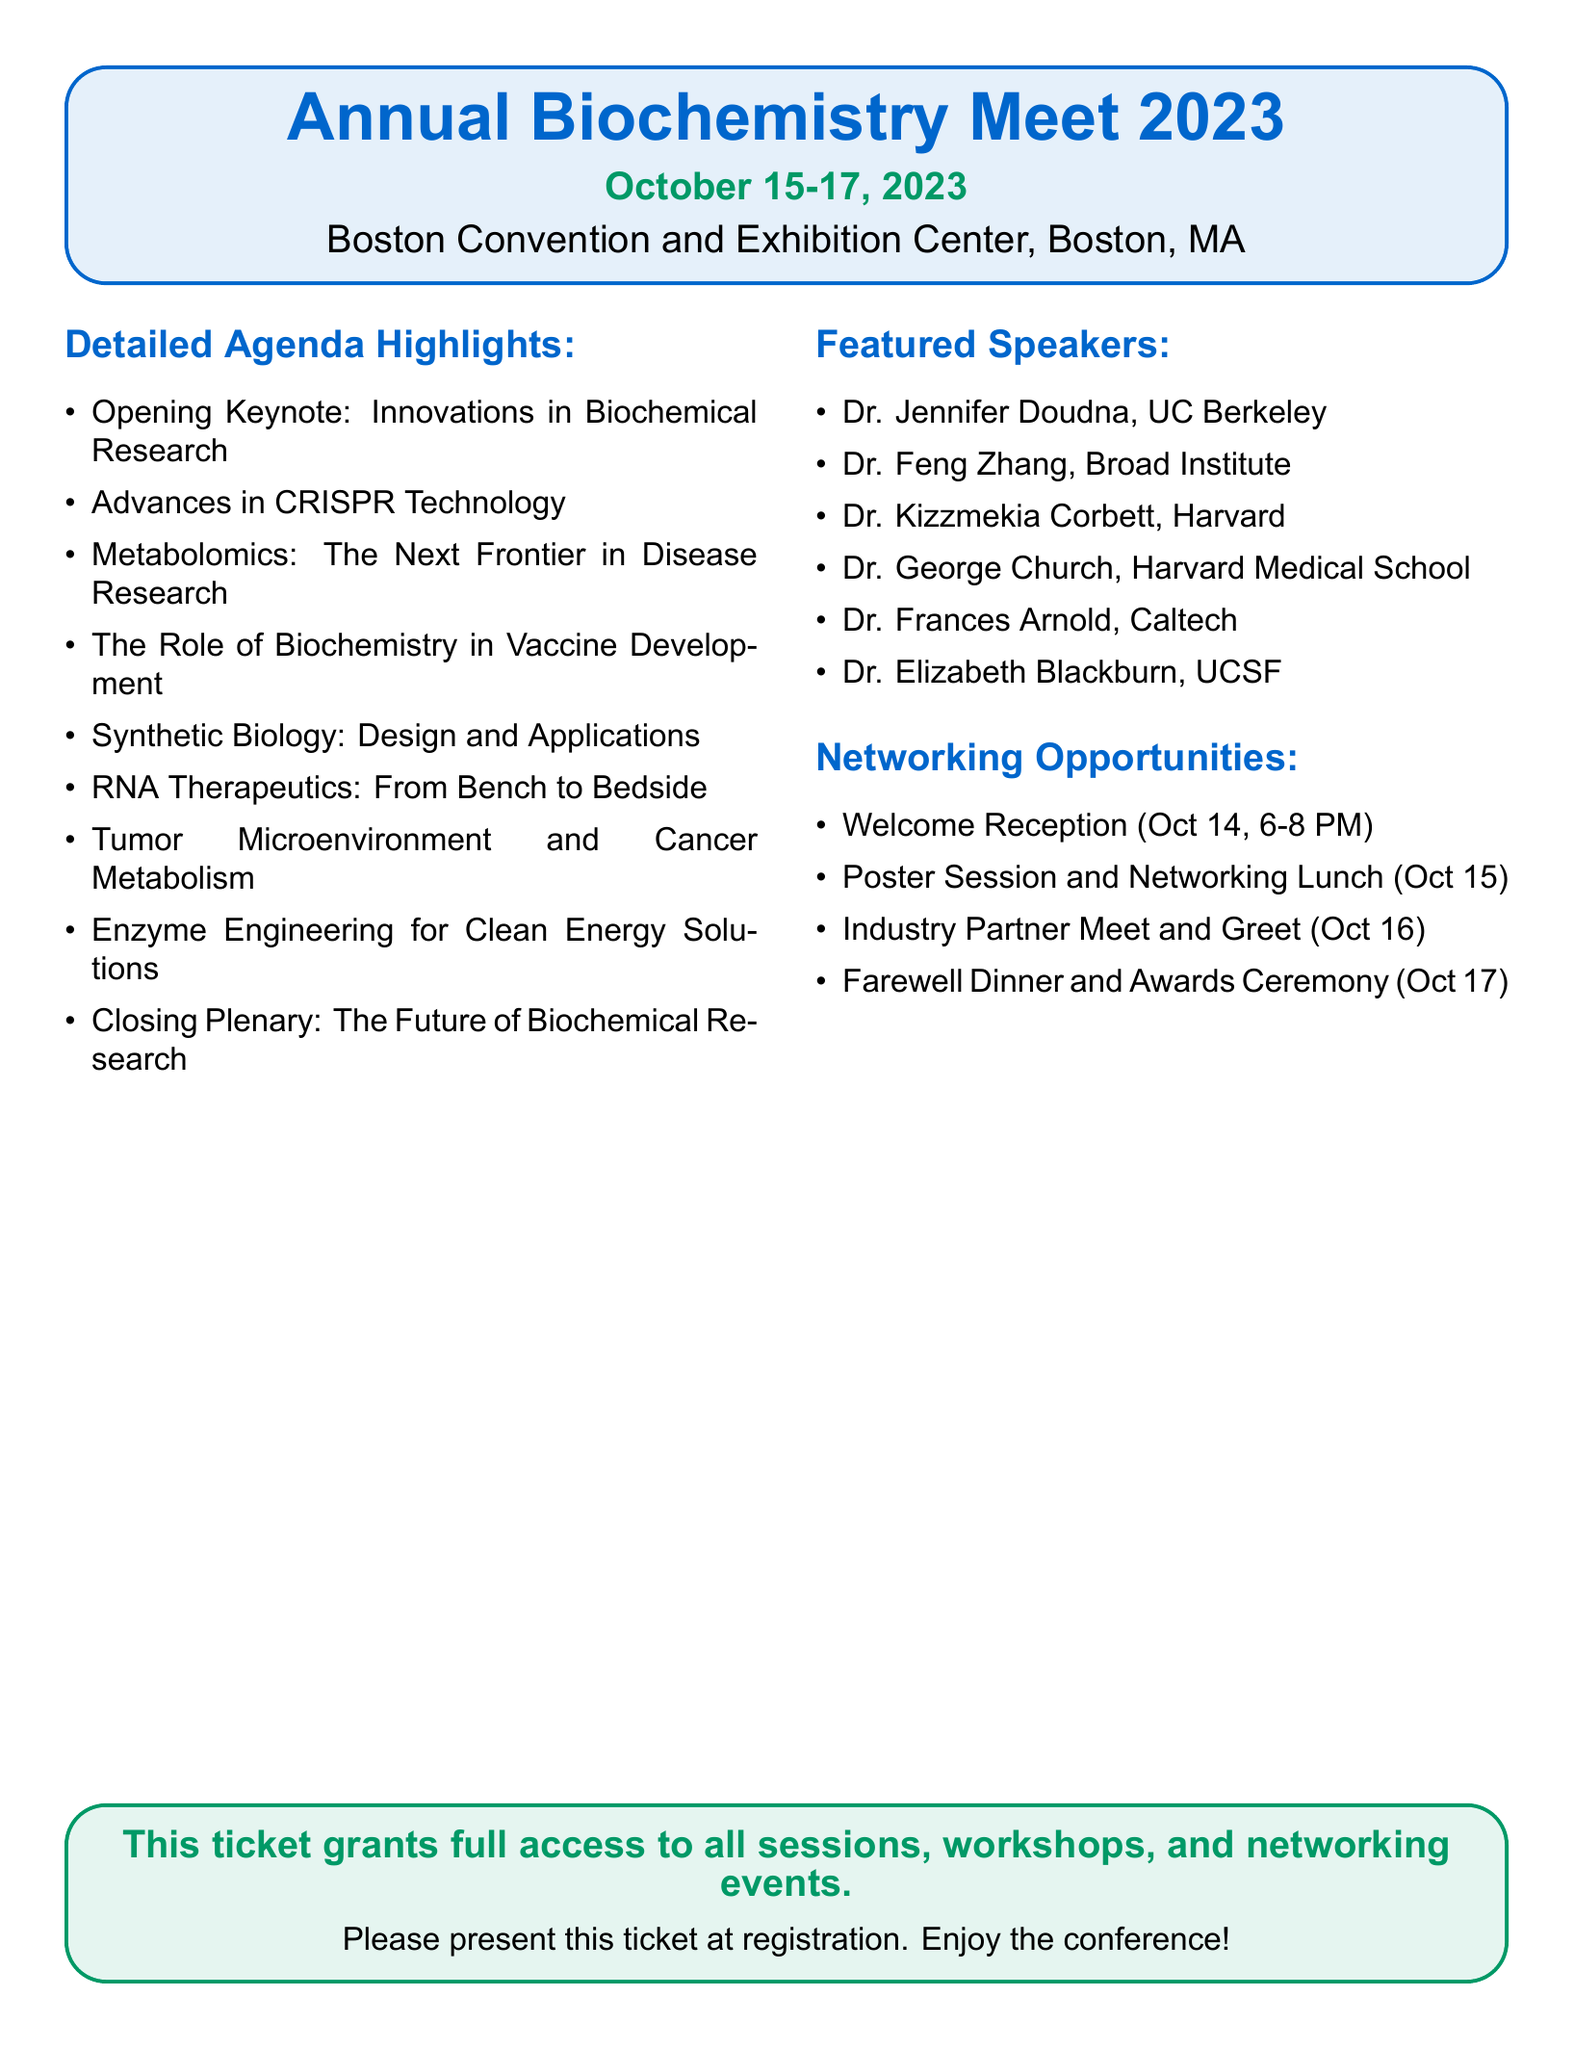what are the dates of the conference? The dates of the conference are explicitly stated in the title, which is October 15-17, 2023.
Answer: October 15-17, 2023 where is the conference taking place? The location of the conference is provided in the document, mentioning the Boston Convention and Exhibition Center, Boston, MA.
Answer: Boston Convention and Exhibition Center, Boston, MA who is the opening keynote speaker? The opening keynote is listed under the agenda highlights, which states "Innovations in Biochemical Research." The speaker's name is not specified for the opening keynote.
Answer: Not specified how many featured speakers are there? The document lists six names under featured speakers, providing a count of them.
Answer: 6 what networking opportunity occurs on October 16? The networking opportunity on October 16 is specified as "Industry Partner Meet and Greet."
Answer: Industry Partner Meet and Greet which session topic relates to cancer research? The session topic that relates to cancer research is "Tumor Microenvironment and Cancer Metabolism" mentioned in the agenda highlights.
Answer: Tumor Microenvironment and Cancer Metabolism what is included with this ticket? The document indicates that the ticket grants full access to all sessions, workshops, and networking events.
Answer: Full access to all sessions, workshops, and networking events what is the farewell event during the conference? The farewell event is described in the agenda highlights, listed as "Farewell Dinner and Awards Ceremony."
Answer: Farewell Dinner and Awards Ceremony 